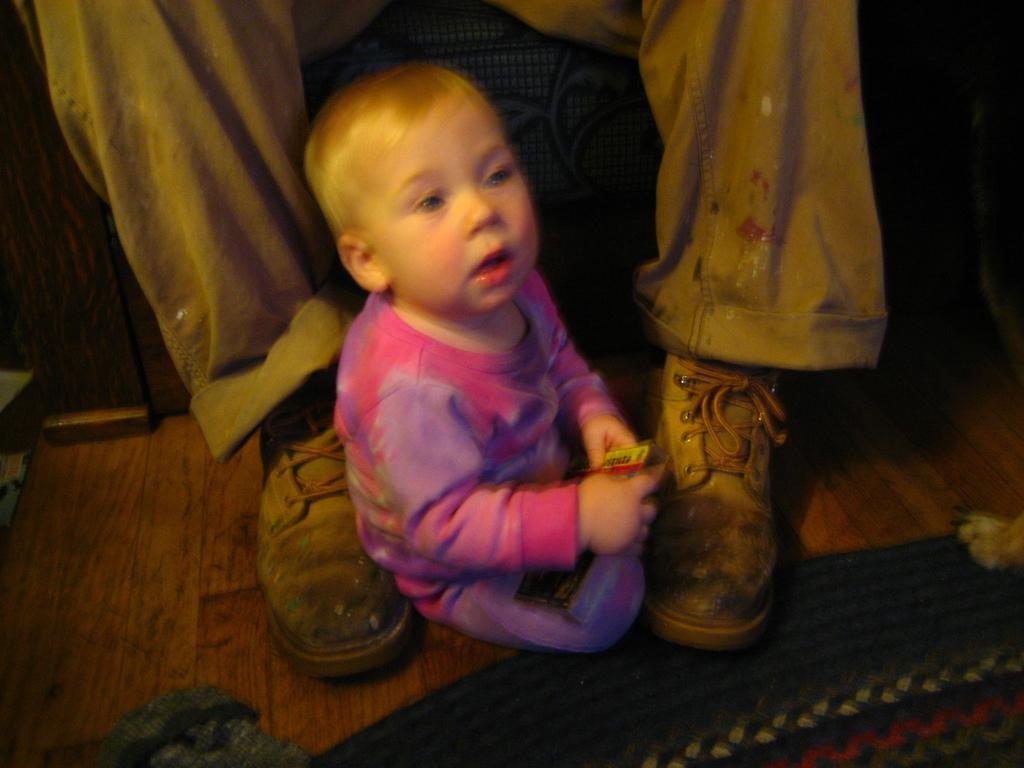Could you give a brief overview of what you see in this image? In this image I can see a baby sitting and wearing purple and pink dress. I can see a person legs and shoes. I can see a mat on the brown color floor. 